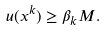Convert formula to latex. <formula><loc_0><loc_0><loc_500><loc_500>u ( x ^ { k } ) \geq \beta _ { k } M .</formula> 